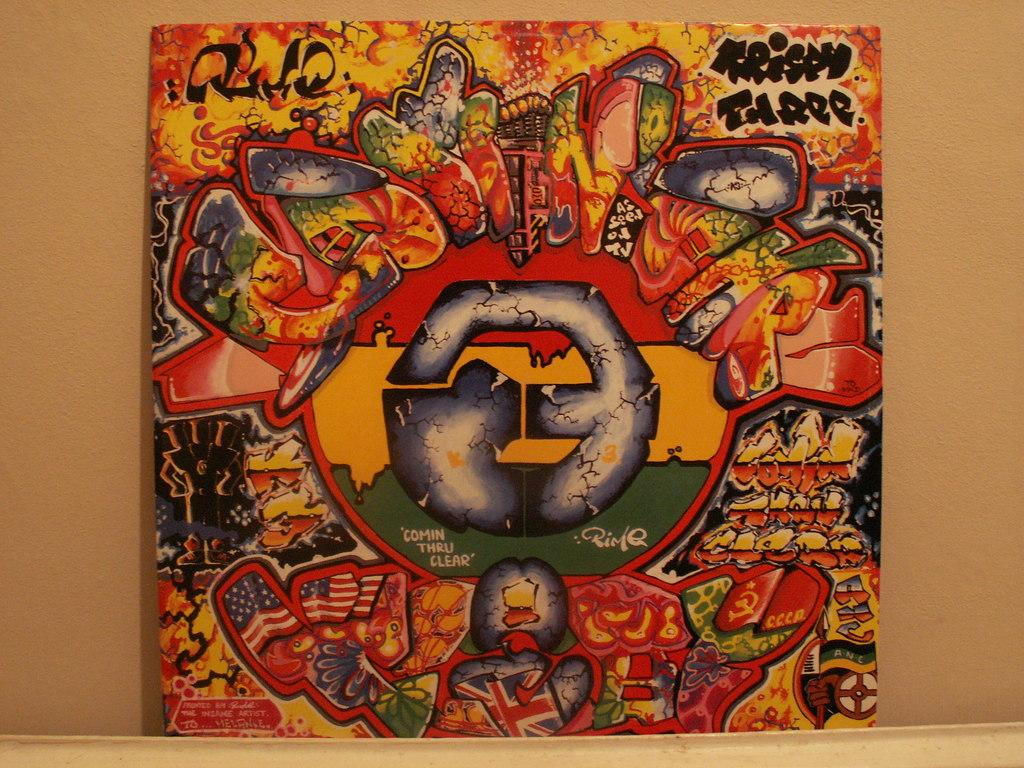What is the main object in the image? There is a board with images in the image. What else can be seen on the board? There is text on the board. Where is the board located in the image? The board is placed in front of a wall. What type of attraction is depicted in the image? There is no attraction depicted in the image; it features a board with images and text. What is the title of the book shown on the board? There is no book shown on the board in the image. 